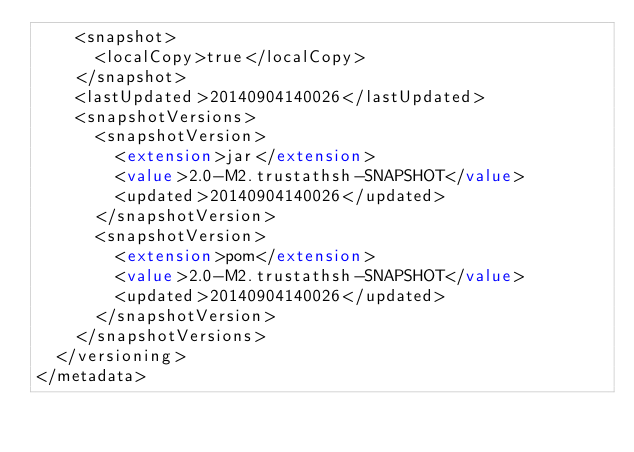<code> <loc_0><loc_0><loc_500><loc_500><_XML_>    <snapshot>
      <localCopy>true</localCopy>
    </snapshot>
    <lastUpdated>20140904140026</lastUpdated>
    <snapshotVersions>
      <snapshotVersion>
        <extension>jar</extension>
        <value>2.0-M2.trustathsh-SNAPSHOT</value>
        <updated>20140904140026</updated>
      </snapshotVersion>
      <snapshotVersion>
        <extension>pom</extension>
        <value>2.0-M2.trustathsh-SNAPSHOT</value>
        <updated>20140904140026</updated>
      </snapshotVersion>
    </snapshotVersions>
  </versioning>
</metadata>
</code> 